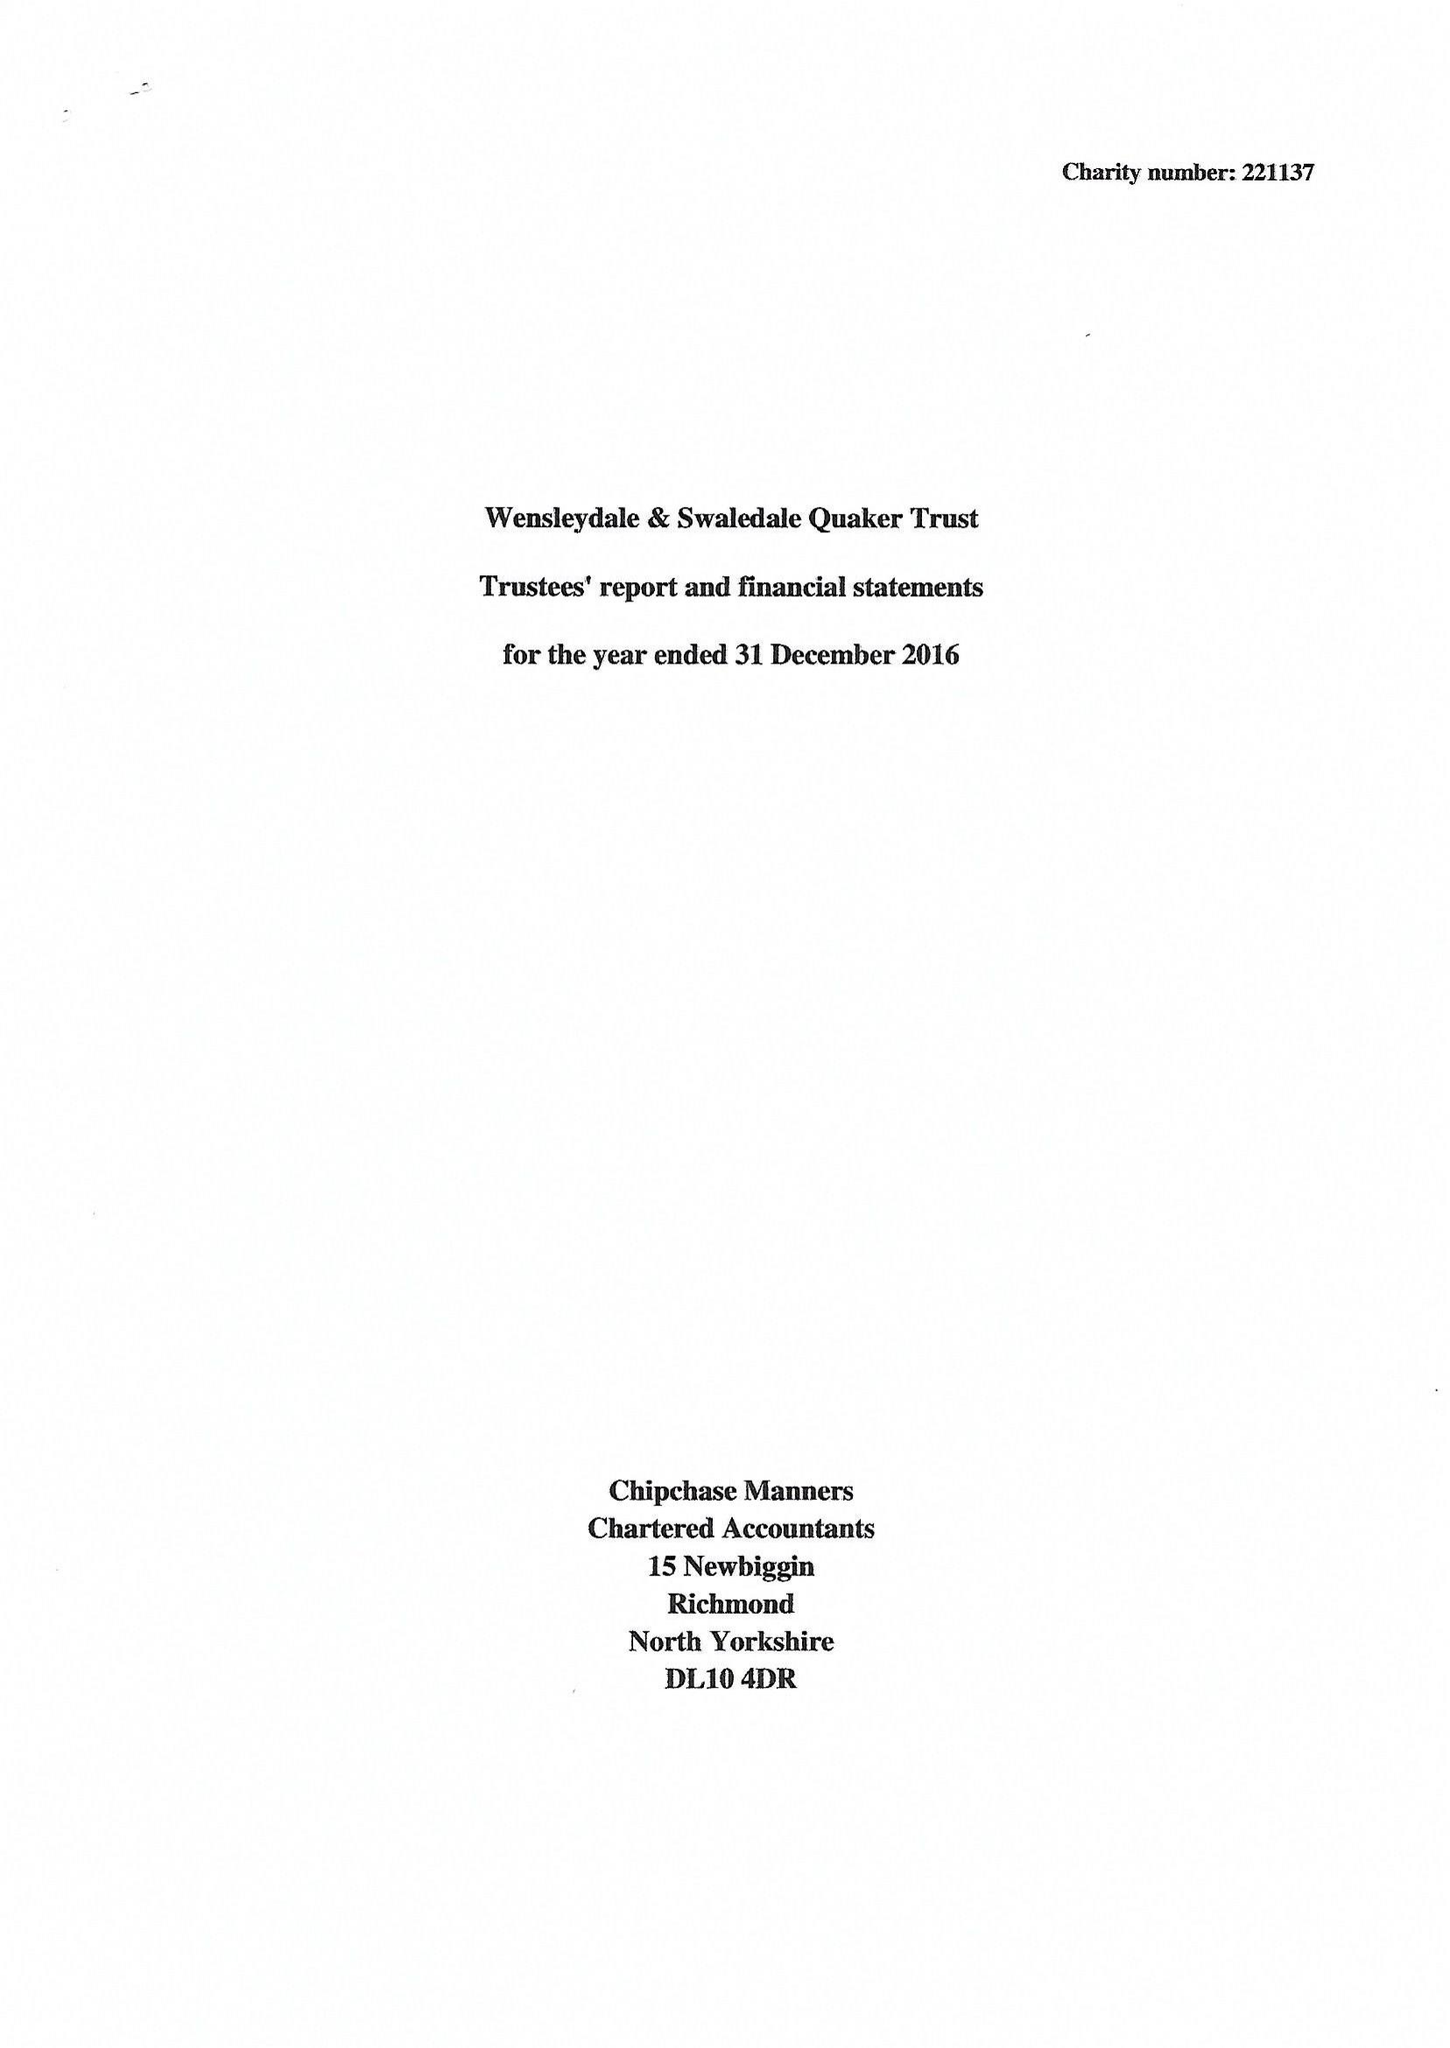What is the value for the charity_number?
Answer the question using a single word or phrase. 221137 